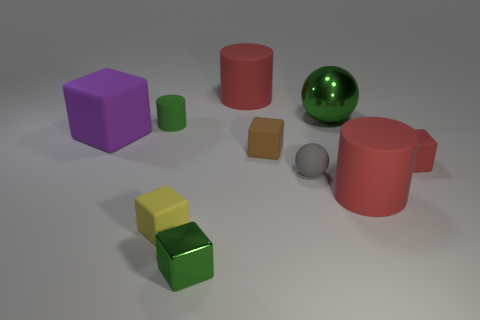Subtract all large cylinders. How many cylinders are left? 1 Subtract all blue balls. How many red cylinders are left? 2 Subtract all yellow blocks. How many blocks are left? 4 Subtract 1 spheres. How many spheres are left? 1 Subtract all cylinders. How many objects are left? 7 Add 6 big gray objects. How many big gray objects exist? 6 Subtract 1 green spheres. How many objects are left? 9 Subtract all yellow cylinders. Subtract all purple cubes. How many cylinders are left? 3 Subtract all small rubber spheres. Subtract all gray rubber things. How many objects are left? 8 Add 8 gray things. How many gray things are left? 9 